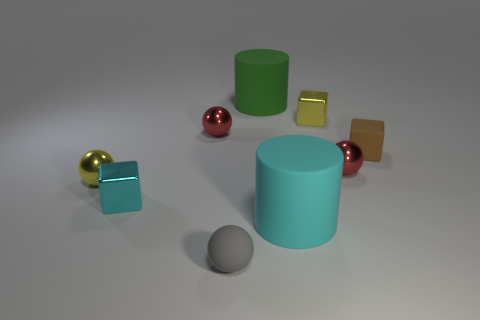Subtract 1 balls. How many balls are left? 3 Subtract all purple balls. Subtract all blue blocks. How many balls are left? 4 Subtract all cylinders. How many objects are left? 7 Subtract all yellow things. Subtract all tiny yellow metal cubes. How many objects are left? 6 Add 8 green matte cylinders. How many green matte cylinders are left? 9 Add 4 yellow shiny spheres. How many yellow shiny spheres exist? 5 Subtract 1 green cylinders. How many objects are left? 8 